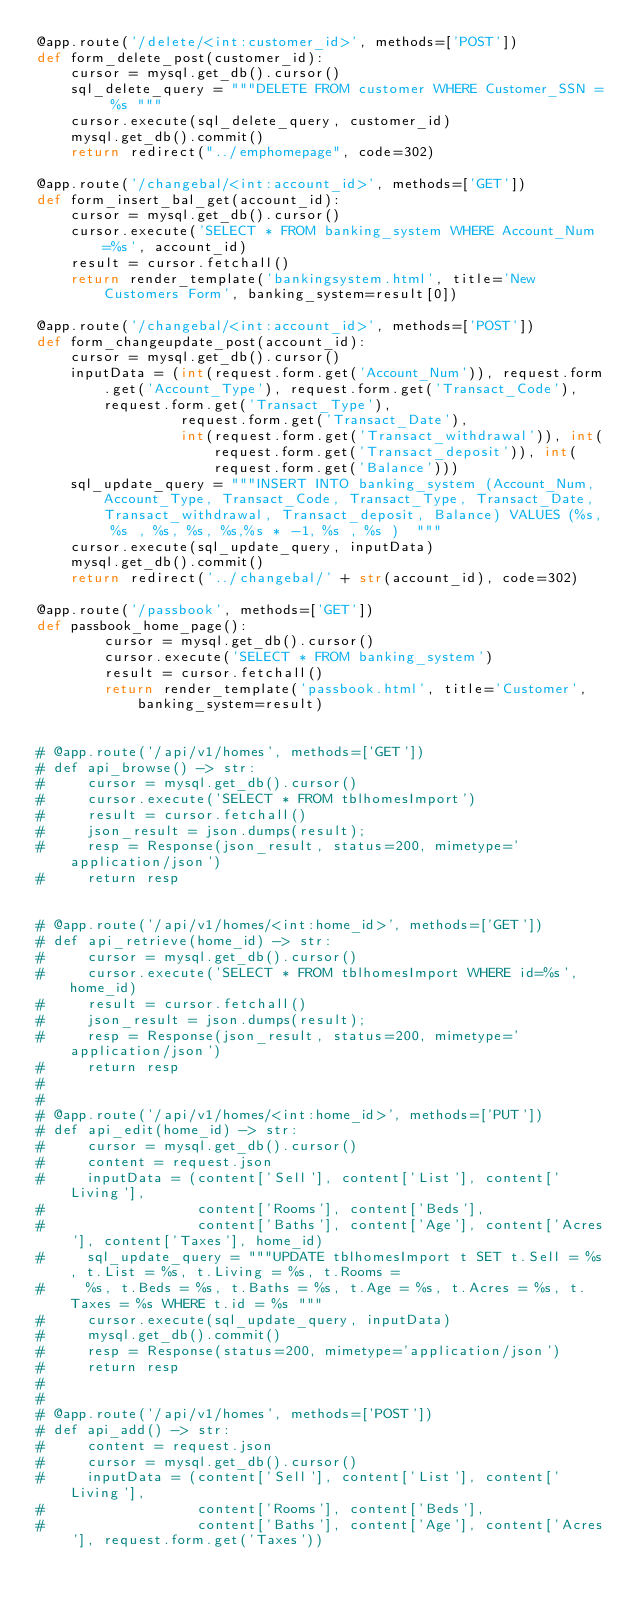<code> <loc_0><loc_0><loc_500><loc_500><_Python_>@app.route('/delete/<int:customer_id>', methods=['POST'])
def form_delete_post(customer_id):
    cursor = mysql.get_db().cursor()
    sql_delete_query = """DELETE FROM customer WHERE Customer_SSN = %s """
    cursor.execute(sql_delete_query, customer_id)
    mysql.get_db().commit()
    return redirect("../emphomepage", code=302)

@app.route('/changebal/<int:account_id>', methods=['GET'])
def form_insert_bal_get(account_id):
    cursor = mysql.get_db().cursor()
    cursor.execute('SELECT * FROM banking_system WHERE Account_Num=%s', account_id)
    result = cursor.fetchall()
    return render_template('bankingsystem.html', title='New Customers Form', banking_system=result[0])

@app.route('/changebal/<int:account_id>', methods=['POST'])
def form_changeupdate_post(account_id):
    cursor = mysql.get_db().cursor()
    inputData = (int(request.form.get('Account_Num')), request.form.get('Account_Type'), request.form.get('Transact_Code'), request.form.get('Transact_Type'),
                 request.form.get('Transact_Date'),
                 int(request.form.get('Transact_withdrawal')), int(request.form.get('Transact_deposit')), int(request.form.get('Balance')))
    sql_update_query = """INSERT INTO banking_system (Account_Num, Account_Type, Transact_Code, Transact_Type, Transact_Date,Transact_withdrawal, Transact_deposit, Balance) VALUES (%s, %s , %s, %s, %s,%s * -1, %s , %s )  """
    cursor.execute(sql_update_query, inputData)
    mysql.get_db().commit()
    return redirect('../changebal/' + str(account_id), code=302)

@app.route('/passbook', methods=['GET'])
def passbook_home_page():
        cursor = mysql.get_db().cursor()
        cursor.execute('SELECT * FROM banking_system')
        result = cursor.fetchall()
        return render_template('passbook.html', title='Customer',  banking_system=result)


# @app.route('/api/v1/homes', methods=['GET'])
# def api_browse() -> str:
#     cursor = mysql.get_db().cursor()
#     cursor.execute('SELECT * FROM tblhomesImport')
#     result = cursor.fetchall()
#     json_result = json.dumps(result);
#     resp = Response(json_result, status=200, mimetype='application/json')
#     return resp


# @app.route('/api/v1/homes/<int:home_id>', methods=['GET'])
# def api_retrieve(home_id) -> str:
#     cursor = mysql.get_db().cursor()
#     cursor.execute('SELECT * FROM tblhomesImport WHERE id=%s', home_id)
#     result = cursor.fetchall()
#     json_result = json.dumps(result);
#     resp = Response(json_result, status=200, mimetype='application/json')
#     return resp
#
#
# @app.route('/api/v1/homes/<int:home_id>', methods=['PUT'])
# def api_edit(home_id) -> str:
#     cursor = mysql.get_db().cursor()
#     content = request.json
#     inputData = (content['Sell'], content['List'], content['Living'],
#                  content['Rooms'], content['Beds'],
#                  content['Baths'], content['Age'], content['Acres'], content['Taxes'], home_id)
#     sql_update_query = """UPDATE tblhomesImport t SET t.Sell = %s, t.List = %s, t.Living = %s, t.Rooms =
#     %s, t.Beds = %s, t.Baths = %s, t.Age = %s, t.Acres = %s, t.Taxes = %s WHERE t.id = %s """
#     cursor.execute(sql_update_query, inputData)
#     mysql.get_db().commit()
#     resp = Response(status=200, mimetype='application/json')
#     return resp
#
#
# @app.route('/api/v1/homes', methods=['POST'])
# def api_add() -> str:
#     content = request.json
#     cursor = mysql.get_db().cursor()
#     inputData = (content['Sell'], content['List'], content['Living'],
#                  content['Rooms'], content['Beds'],
#                  content['Baths'], content['Age'], content['Acres'], request.form.get('Taxes'))</code> 